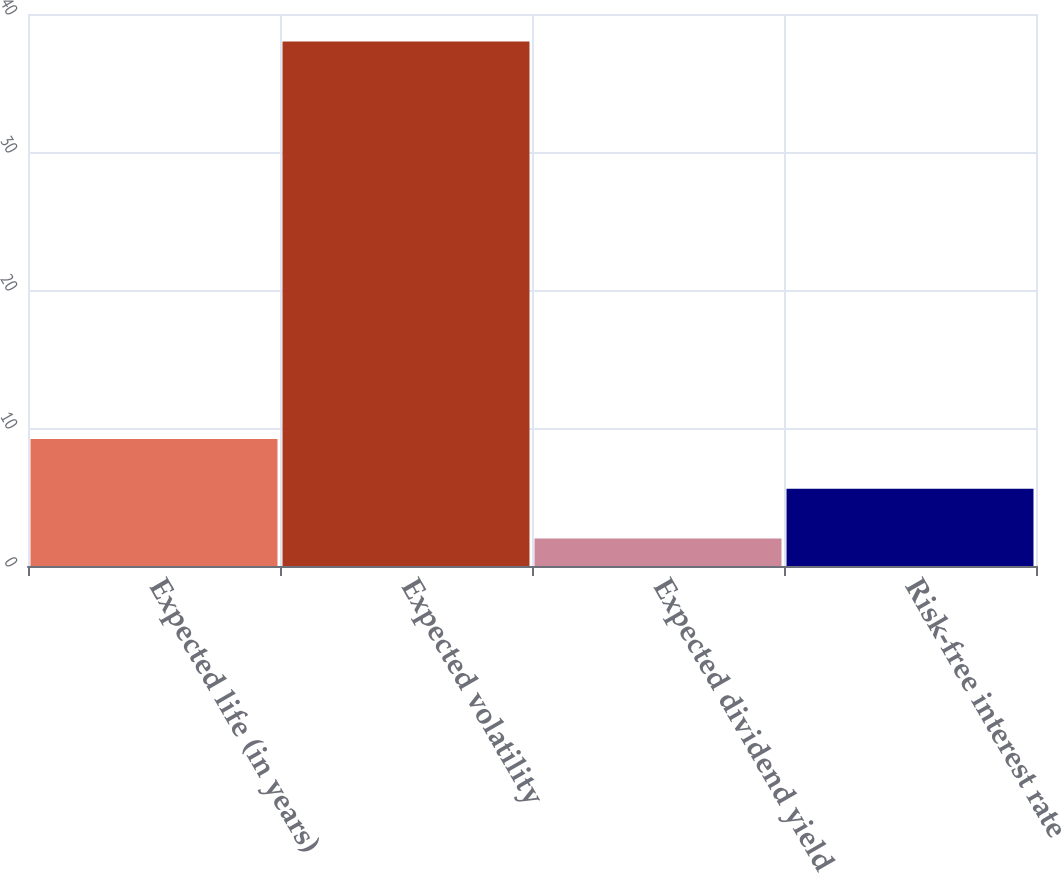Convert chart. <chart><loc_0><loc_0><loc_500><loc_500><bar_chart><fcel>Expected life (in years)<fcel>Expected volatility<fcel>Expected dividend yield<fcel>Risk-free interest rate<nl><fcel>9.2<fcel>38<fcel>2<fcel>5.6<nl></chart> 